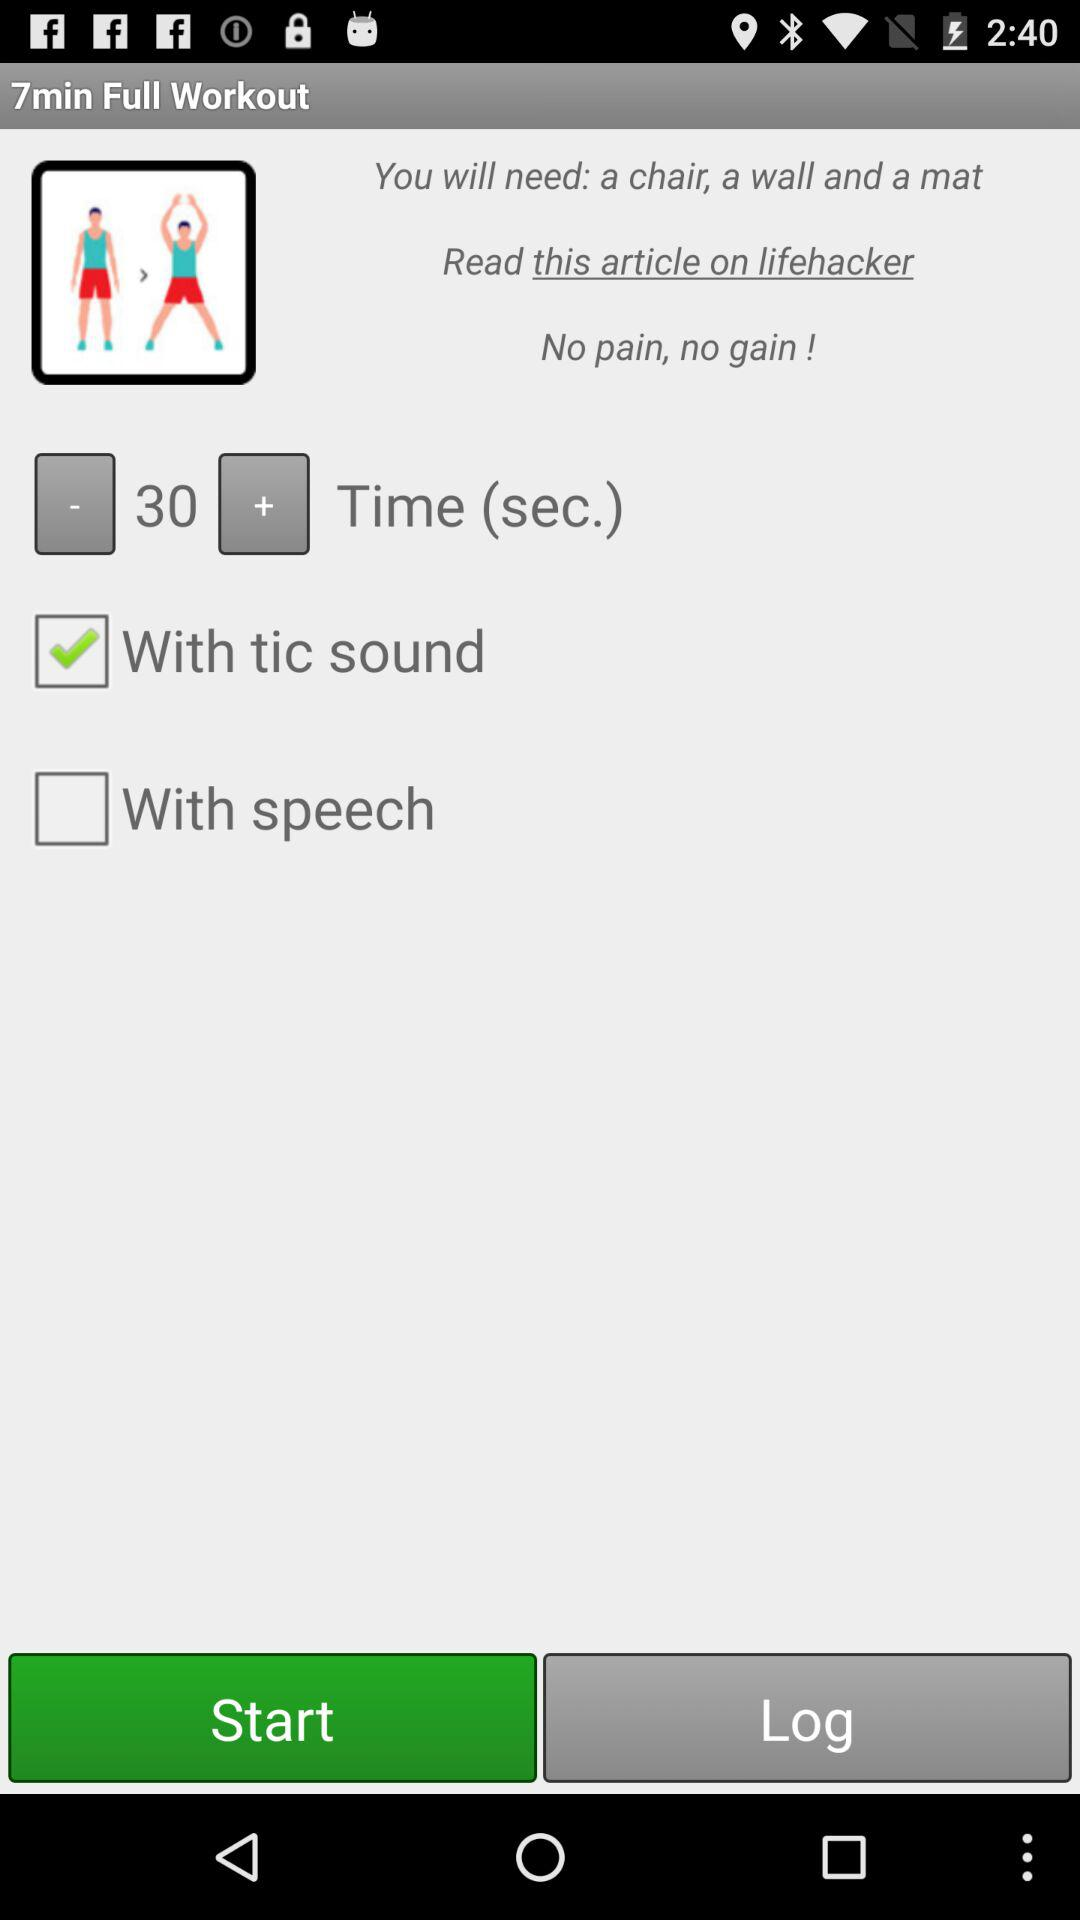How many minutes are there for the full workout?
When the provided information is insufficient, respond with <no answer>. <no answer> 